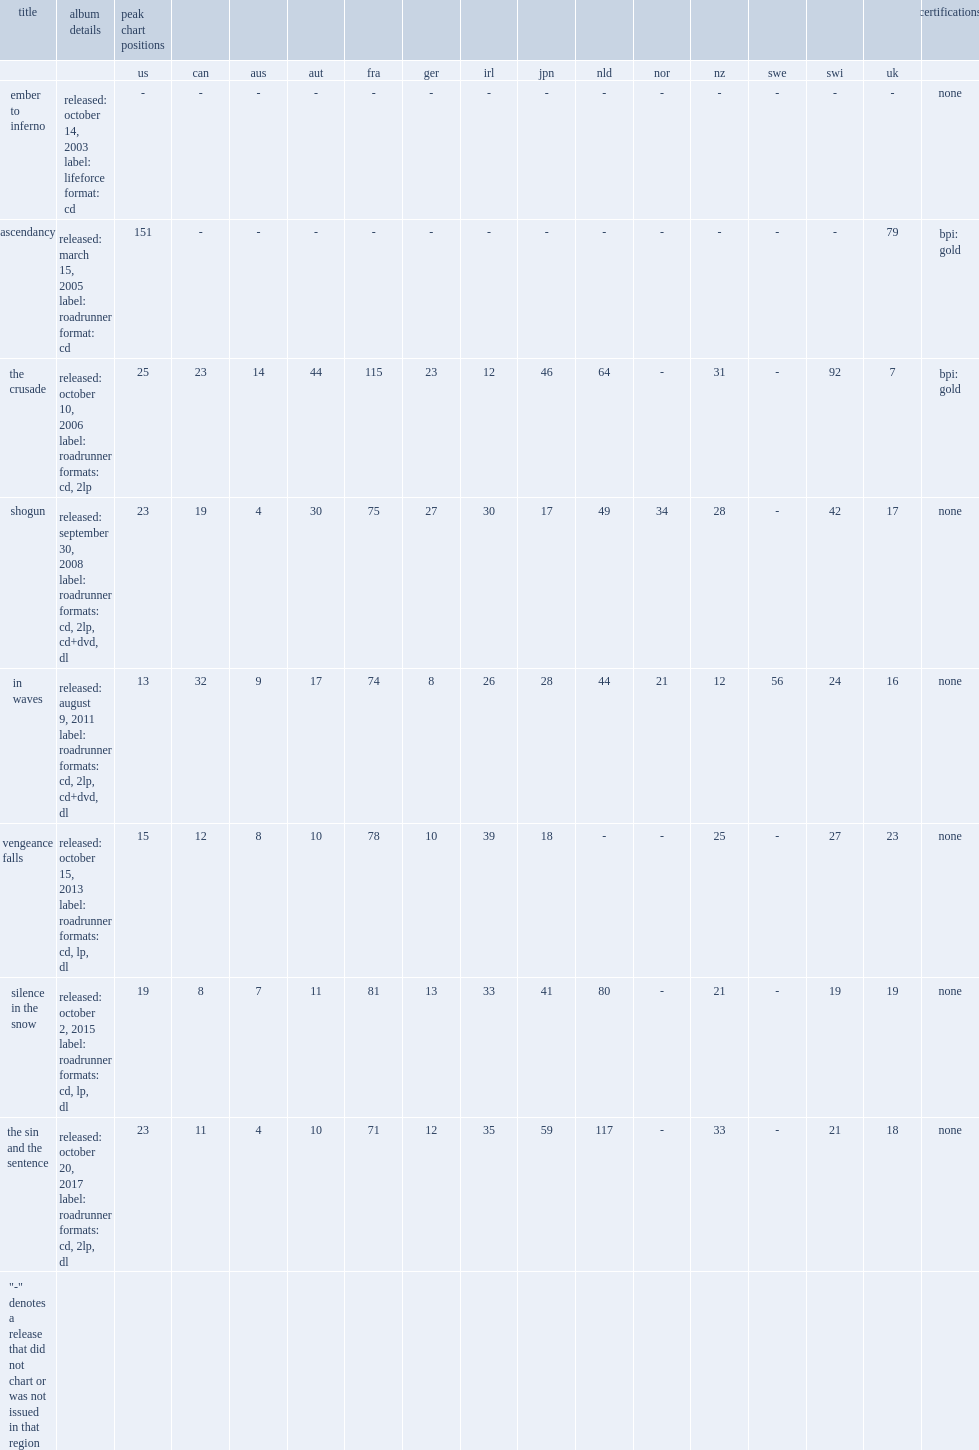What was the peak chart position on the us chart of ascendancy? 151.0. 